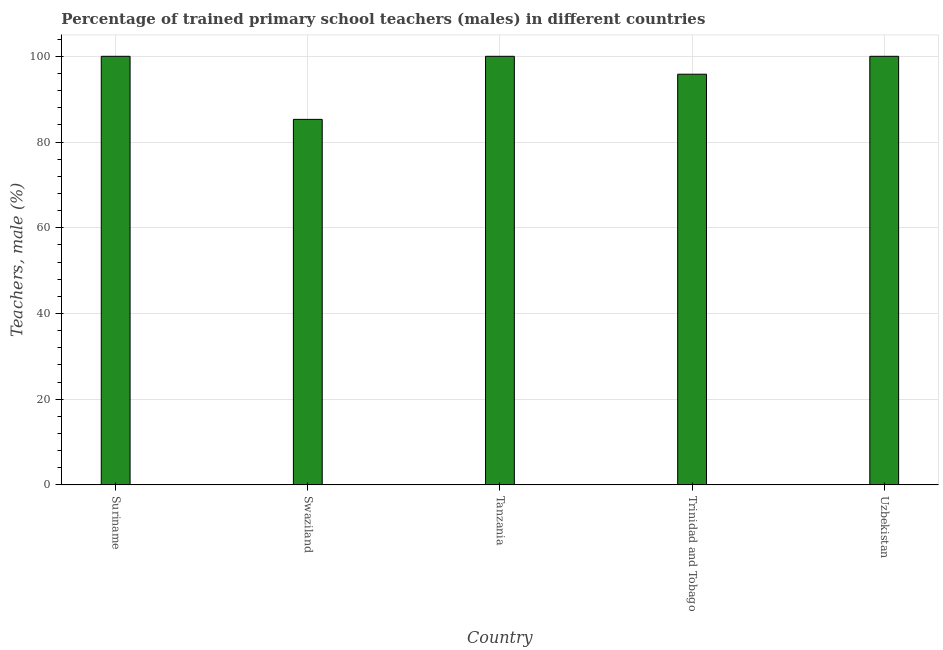Does the graph contain any zero values?
Your answer should be compact. No. Does the graph contain grids?
Offer a very short reply. Yes. What is the title of the graph?
Make the answer very short. Percentage of trained primary school teachers (males) in different countries. What is the label or title of the X-axis?
Provide a succinct answer. Country. What is the label or title of the Y-axis?
Make the answer very short. Teachers, male (%). What is the percentage of trained male teachers in Trinidad and Tobago?
Offer a very short reply. 95.82. Across all countries, what is the minimum percentage of trained male teachers?
Give a very brief answer. 85.29. In which country was the percentage of trained male teachers maximum?
Your answer should be compact. Suriname. In which country was the percentage of trained male teachers minimum?
Your answer should be compact. Swaziland. What is the sum of the percentage of trained male teachers?
Your response must be concise. 481.11. What is the difference between the percentage of trained male teachers in Suriname and Swaziland?
Provide a succinct answer. 14.71. What is the average percentage of trained male teachers per country?
Give a very brief answer. 96.22. What is the median percentage of trained male teachers?
Your answer should be compact. 100. What is the ratio of the percentage of trained male teachers in Swaziland to that in Trinidad and Tobago?
Your answer should be compact. 0.89. Is the difference between the percentage of trained male teachers in Trinidad and Tobago and Uzbekistan greater than the difference between any two countries?
Make the answer very short. No. What is the difference between the highest and the second highest percentage of trained male teachers?
Provide a short and direct response. 0. Is the sum of the percentage of trained male teachers in Trinidad and Tobago and Uzbekistan greater than the maximum percentage of trained male teachers across all countries?
Give a very brief answer. Yes. What is the difference between the highest and the lowest percentage of trained male teachers?
Provide a succinct answer. 14.71. Are the values on the major ticks of Y-axis written in scientific E-notation?
Ensure brevity in your answer.  No. What is the Teachers, male (%) in Suriname?
Your answer should be compact. 100. What is the Teachers, male (%) in Swaziland?
Keep it short and to the point. 85.29. What is the Teachers, male (%) of Tanzania?
Provide a succinct answer. 100. What is the Teachers, male (%) of Trinidad and Tobago?
Provide a succinct answer. 95.82. What is the difference between the Teachers, male (%) in Suriname and Swaziland?
Ensure brevity in your answer.  14.71. What is the difference between the Teachers, male (%) in Suriname and Trinidad and Tobago?
Provide a succinct answer. 4.18. What is the difference between the Teachers, male (%) in Suriname and Uzbekistan?
Offer a very short reply. 0. What is the difference between the Teachers, male (%) in Swaziland and Tanzania?
Provide a succinct answer. -14.71. What is the difference between the Teachers, male (%) in Swaziland and Trinidad and Tobago?
Provide a succinct answer. -10.54. What is the difference between the Teachers, male (%) in Swaziland and Uzbekistan?
Ensure brevity in your answer.  -14.71. What is the difference between the Teachers, male (%) in Tanzania and Trinidad and Tobago?
Provide a short and direct response. 4.18. What is the difference between the Teachers, male (%) in Trinidad and Tobago and Uzbekistan?
Your answer should be very brief. -4.18. What is the ratio of the Teachers, male (%) in Suriname to that in Swaziland?
Your response must be concise. 1.17. What is the ratio of the Teachers, male (%) in Suriname to that in Trinidad and Tobago?
Offer a very short reply. 1.04. What is the ratio of the Teachers, male (%) in Swaziland to that in Tanzania?
Offer a very short reply. 0.85. What is the ratio of the Teachers, male (%) in Swaziland to that in Trinidad and Tobago?
Your response must be concise. 0.89. What is the ratio of the Teachers, male (%) in Swaziland to that in Uzbekistan?
Make the answer very short. 0.85. What is the ratio of the Teachers, male (%) in Tanzania to that in Trinidad and Tobago?
Give a very brief answer. 1.04. What is the ratio of the Teachers, male (%) in Tanzania to that in Uzbekistan?
Provide a succinct answer. 1. What is the ratio of the Teachers, male (%) in Trinidad and Tobago to that in Uzbekistan?
Your answer should be compact. 0.96. 